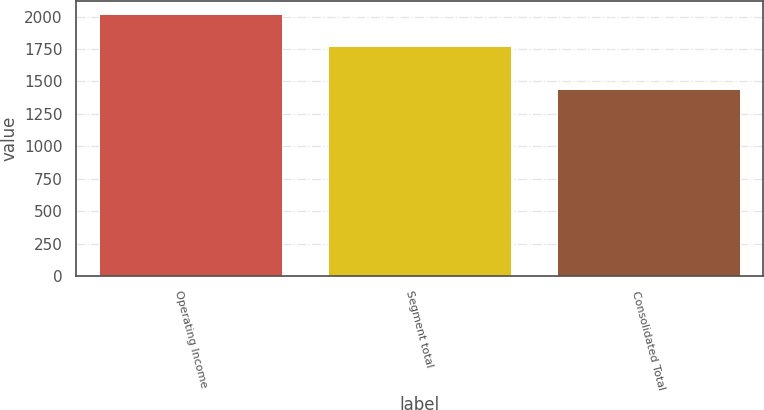<chart> <loc_0><loc_0><loc_500><loc_500><bar_chart><fcel>Operating Income<fcel>Segment total<fcel>Consolidated Total<nl><fcel>2017<fcel>1773.8<fcel>1440<nl></chart> 